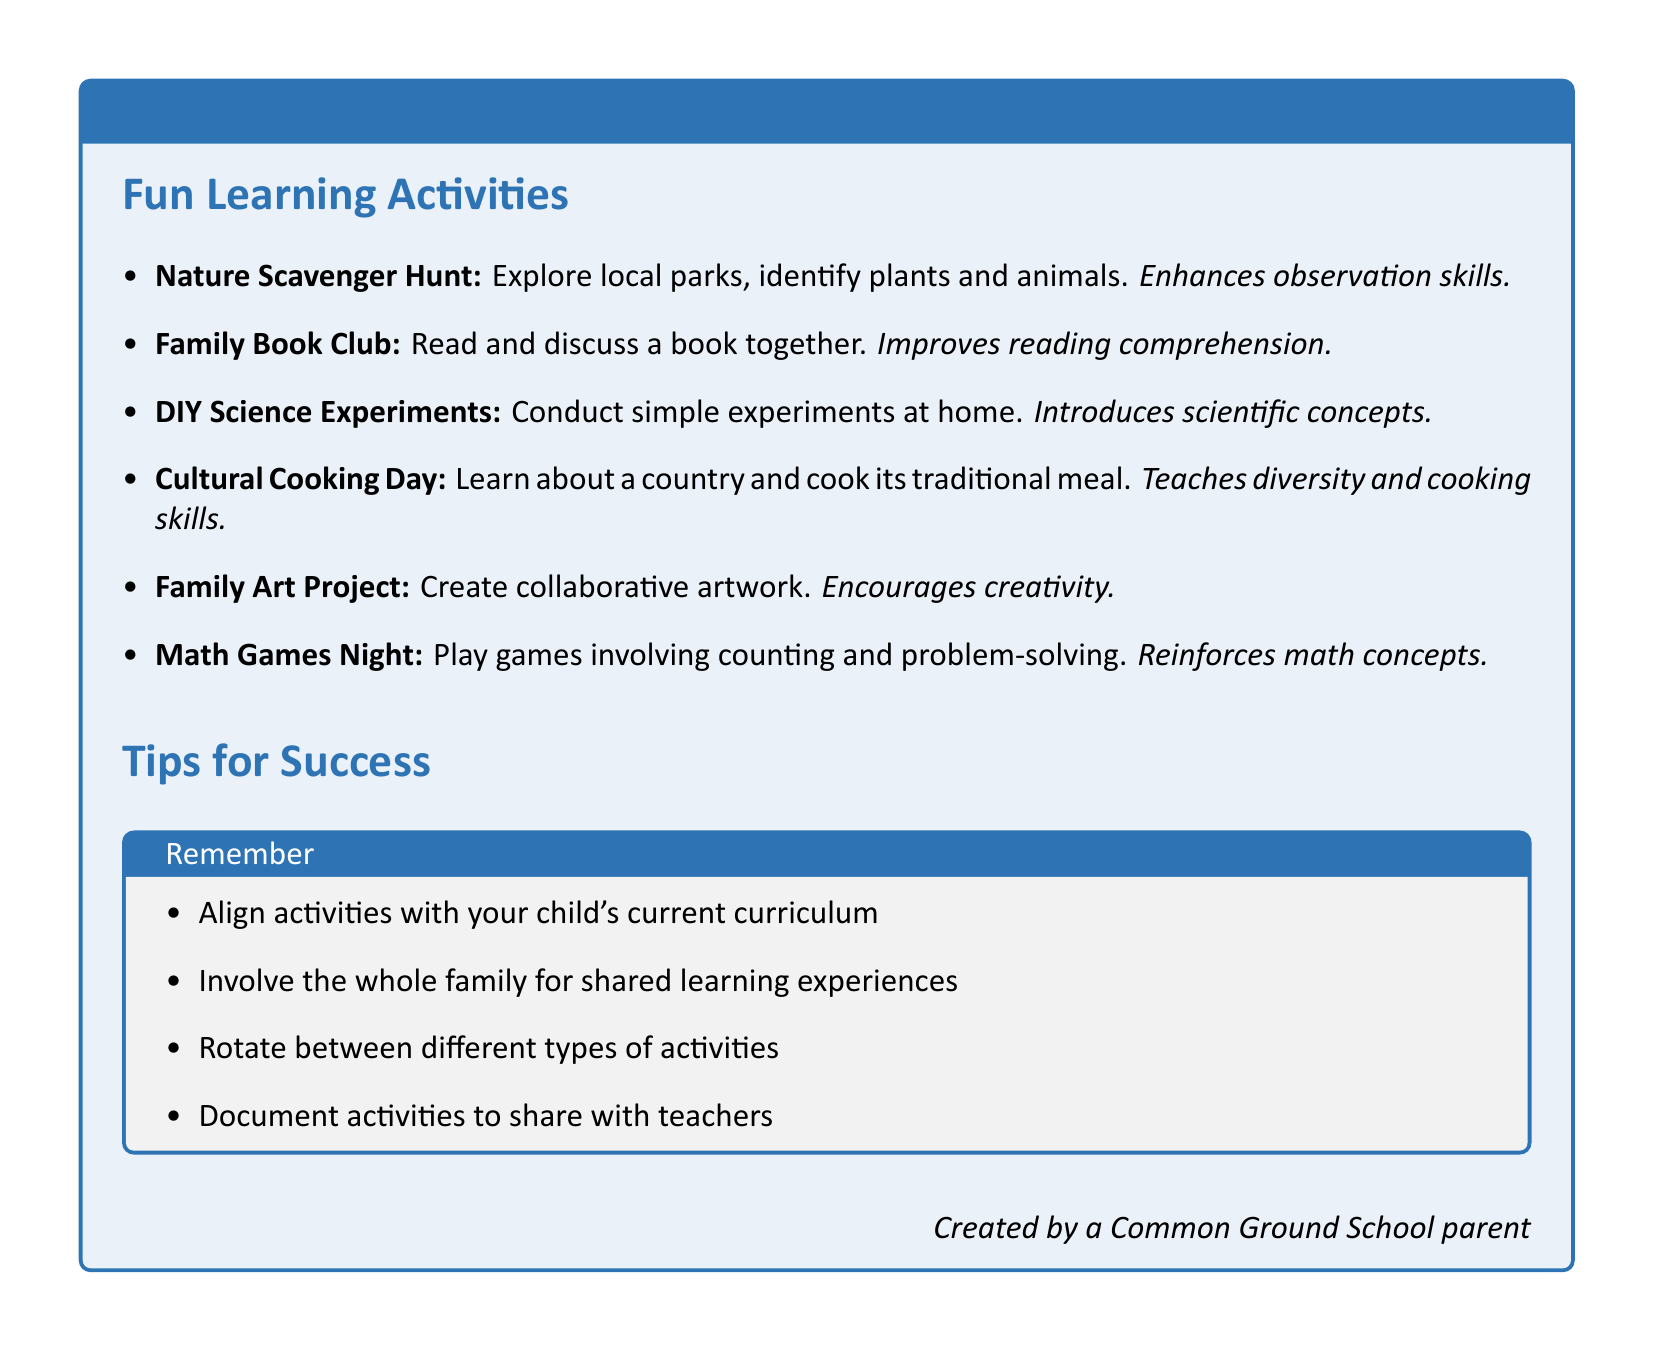What is the title of the document? The title is clearly stated at the beginning of the document.
Answer: Weekend Family Activities for Common Ground School Families How many activities are listed in the document? The total number of activities can be counted from the "Fun Learning Activities" section.
Answer: Six What activity improves reading comprehension? The educational benefit associated with one of the listed activities mentions reading comprehension specifically.
Answer: Family Book Club What is the educational benefit of the Family Art Project? The document provides educational benefits for each activity, including the Family Art Project.
Answer: Encourages creativity and fine motor skills development Which activity involves cooking? The description of this activity mentions learning about a country's culture and cooking a traditional meal.
Answer: Cultural Cooking Day What is one tip for success mentioned in the document? The tips section offers suggestions for enhancing the activities described.
Answer: Align activities with your child's current curriculum What type of games are suggested for Math Games Night? The document specifies the type of games that help reinforce mathematical concepts.
Answer: Board games or card games Which activity fosters curiosity? The educational benefit of this activity indicates that it introduces scientific concepts and fosters curiosity.
Answer: DIY Science Experiments 